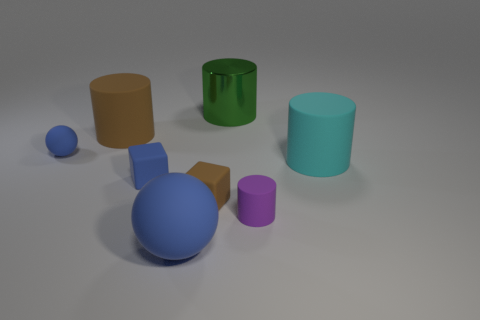Subtract all green cylinders. How many cylinders are left? 3 Subtract all green cylinders. How many cylinders are left? 3 Add 1 tiny blue matte things. How many objects exist? 9 Subtract all gray cylinders. Subtract all brown balls. How many cylinders are left? 4 Subtract all cubes. How many objects are left? 6 Add 4 small blue balls. How many small blue balls are left? 5 Add 6 small rubber cylinders. How many small rubber cylinders exist? 7 Subtract 0 red cubes. How many objects are left? 8 Subtract all tiny purple rubber cylinders. Subtract all big yellow things. How many objects are left? 7 